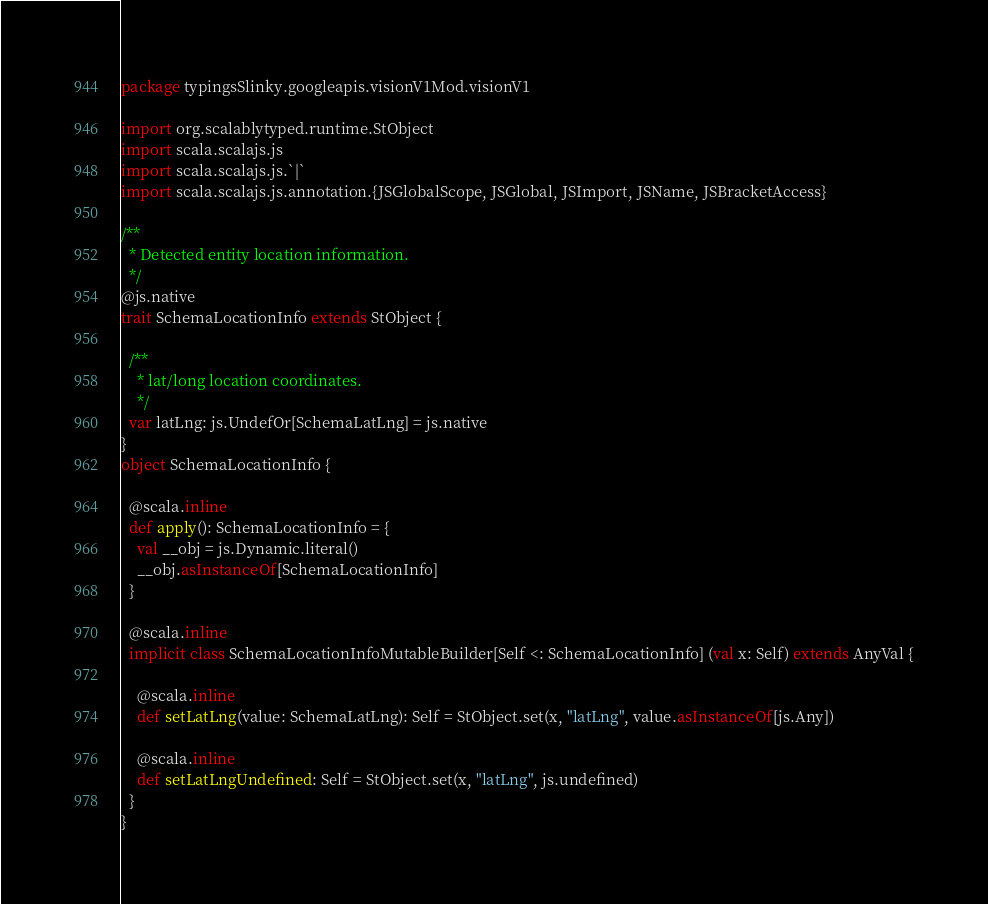Convert code to text. <code><loc_0><loc_0><loc_500><loc_500><_Scala_>package typingsSlinky.googleapis.visionV1Mod.visionV1

import org.scalablytyped.runtime.StObject
import scala.scalajs.js
import scala.scalajs.js.`|`
import scala.scalajs.js.annotation.{JSGlobalScope, JSGlobal, JSImport, JSName, JSBracketAccess}

/**
  * Detected entity location information.
  */
@js.native
trait SchemaLocationInfo extends StObject {
  
  /**
    * lat/long location coordinates.
    */
  var latLng: js.UndefOr[SchemaLatLng] = js.native
}
object SchemaLocationInfo {
  
  @scala.inline
  def apply(): SchemaLocationInfo = {
    val __obj = js.Dynamic.literal()
    __obj.asInstanceOf[SchemaLocationInfo]
  }
  
  @scala.inline
  implicit class SchemaLocationInfoMutableBuilder[Self <: SchemaLocationInfo] (val x: Self) extends AnyVal {
    
    @scala.inline
    def setLatLng(value: SchemaLatLng): Self = StObject.set(x, "latLng", value.asInstanceOf[js.Any])
    
    @scala.inline
    def setLatLngUndefined: Self = StObject.set(x, "latLng", js.undefined)
  }
}
</code> 